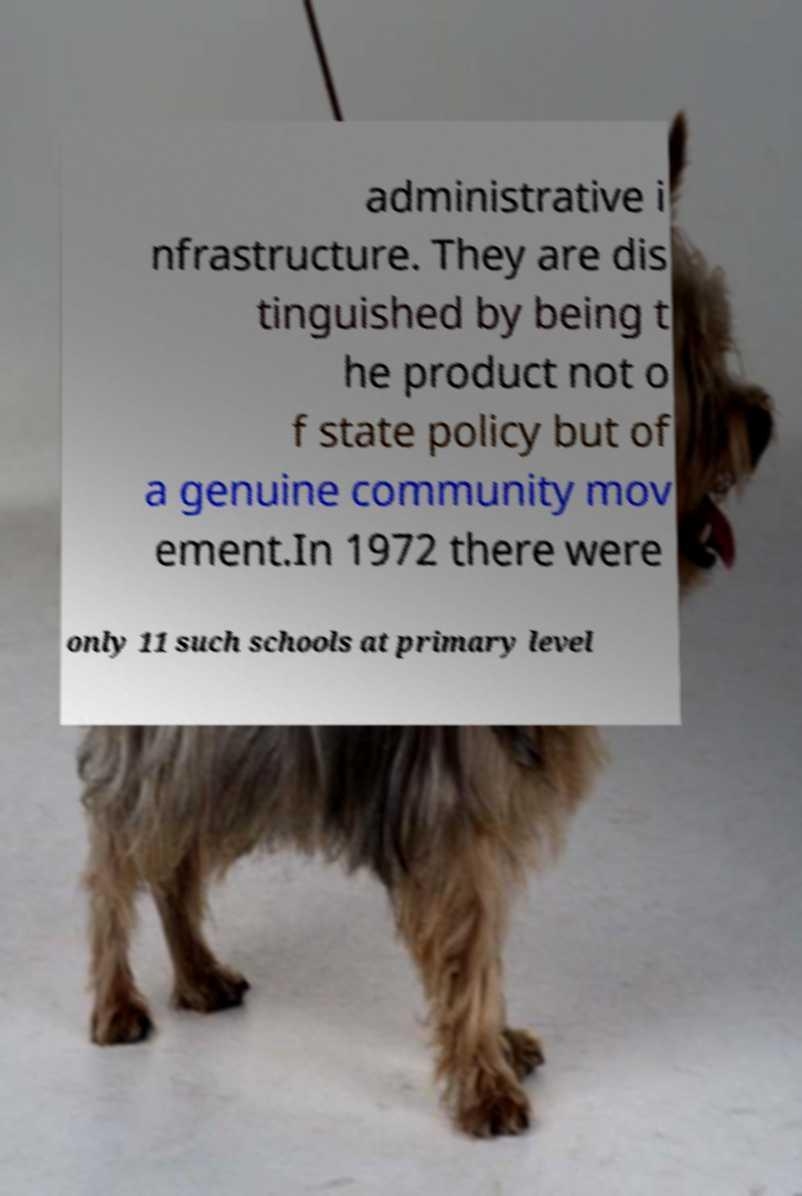Could you assist in decoding the text presented in this image and type it out clearly? administrative i nfrastructure. They are dis tinguished by being t he product not o f state policy but of a genuine community mov ement.In 1972 there were only 11 such schools at primary level 